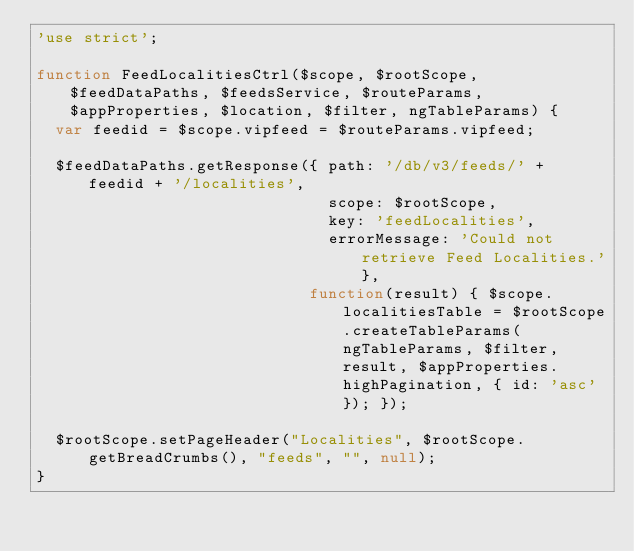<code> <loc_0><loc_0><loc_500><loc_500><_JavaScript_>'use strict';

function FeedLocalitiesCtrl($scope, $rootScope, $feedDataPaths, $feedsService, $routeParams, $appProperties, $location, $filter, ngTableParams) {
  var feedid = $scope.vipfeed = $routeParams.vipfeed;

  $feedDataPaths.getResponse({ path: '/db/v3/feeds/' + feedid + '/localities',
                               scope: $rootScope,
                               key: 'feedLocalities',
                               errorMessage: 'Could not retrieve Feed Localities.'},
                             function(result) { $scope.localitiesTable = $rootScope.createTableParams(ngTableParams, $filter, result, $appProperties.highPagination, { id: 'asc' }); });

  $rootScope.setPageHeader("Localities", $rootScope.getBreadCrumbs(), "feeds", "", null);
}
</code> 